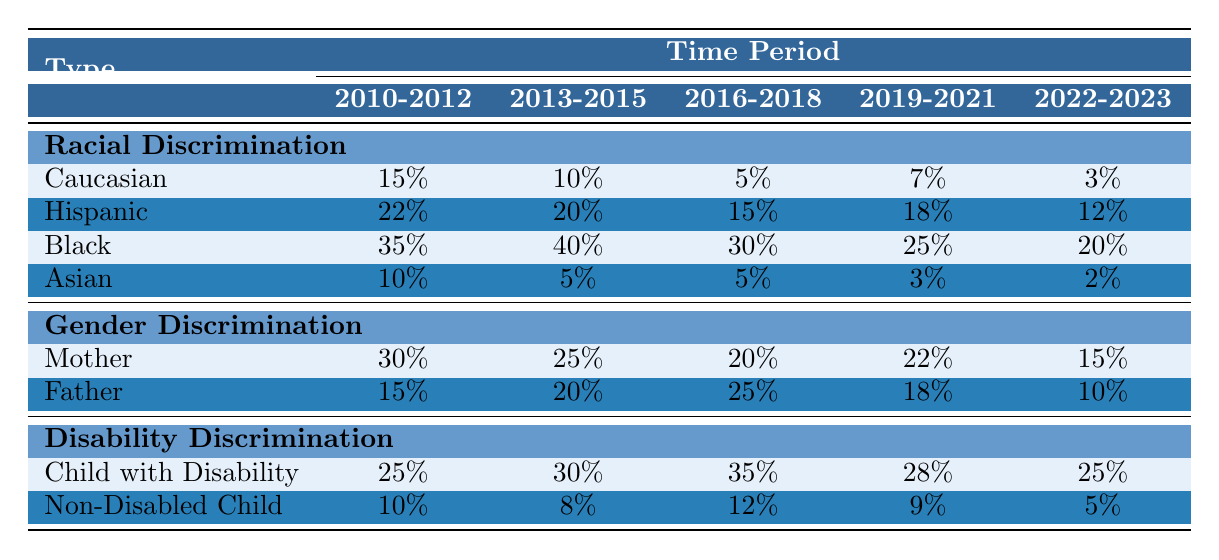What was the percentage of racial discrimination reported by Black parents in the time period 2016-2018? In the table, under racial discrimination for the time period 2016-2018, the percentage reported by Black parents is 30%.
Answer: 30% What is the trend in gender discrimination percentages among mothers from 2010-2012 to 2022-2023? Observing the table, the percentages for mothers are 30% in 2010-2012, decreasing to 15% in 2022-2023. This indicates a downward trend over the years.
Answer: Downward trend Which type of discrimination had the highest percentage for "Child with Disability" in the time period 2016-2018? According to the table, the percentage for "Child with Disability" under disability discrimination is 35% in the time period 2016-2018, which is the highest among all types during that period.
Answer: 35% What was the difference in percentage of racial discrimination reported by Hispanic parents between 2013-2015 and 2022-2023? The table shows that the percentage for Hispanic parents in 2013-2015 is 20% and in 2022-2023 is 12%. The difference is 20% - 12% = 8%.
Answer: 8% Was there an increase in reported racial discrimination for Asian parents from 2019-2021 to 2022-2023? The table indicates a percentage of 3% for Asian parents in 2019-2021 and 2% in 2022-2023. This shows a decrease, not an increase, in reported racial discrimination.
Answer: No Which discrimination type has consistently higher percentages for "Child with Disability" compared to "Non-Disabled Child" across all time periods? By examining the table, "Child with Disability" shows percentages of 25%, 30%, 35%, 28%, and 25%, while "Non-Disabled Child" shows 10%, 8%, 12%, 9%, and 5%. Hence, "Child with Disability" consistently has higher percentages.
Answer: Yes What was the average percentage of gender discrimination reported by fathers over the time periods 2010-2012 to 2022-2023? The percentages for fathers over the given time periods are 15%, 20%, 25%, 18%, and 10%. Adding these percentages gives a total of 88%. Dividing by the 5 time periods results in an average of 88%/5 = 17.6%.
Answer: 17.6% How does the percentage of racial discrimination for Caucasian parents compare to that of Black parents in 2022-2023? In 2022-2023, Caucasian parents reported 3% and Black parents reported 20%. Black parents have a higher percentage of racial discrimination than Caucasian parents in that time period.
Answer: Black parents had a higher percentage What is the total percentage of disability discrimination reported for "Child with Disability" across all time periods? Adding the percentages for "Child with Disability": 25% + 30% + 35% + 28% + 25% equals 173%. Thus, the total is 173%.
Answer: 173% Which type of discrimination saw the greatest percentage increase from 2010-2012 to 2013-2015 for mothers? For mothers, the percentage of gender discrimination decreased from 30% in 2010-2012 to 25% in 2013-2015. Therefore, there is actually a decrease, not an increase.
Answer: No increase In the time period from 2010-2012 to 2022-2023, how much did the reported percentage of racial discrimination change for Black parents? The percentage for Black parents was 35% in 2010-2012 and dropped to 20% in 2022-2023. The change is 35% - 20% = 15% decrease.
Answer: 15% decrease 